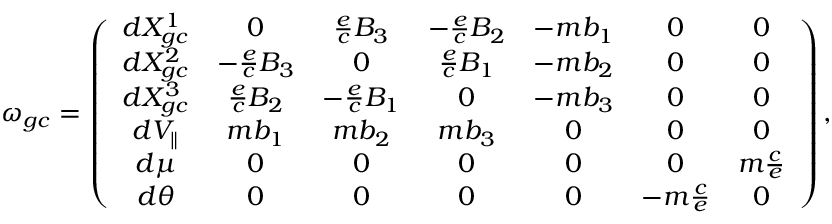<formula> <loc_0><loc_0><loc_500><loc_500>\omega _ { g c } = \left ( \begin{array} { c c c c c c c } { d X _ { g c } ^ { 1 } } & { 0 } & { \frac { e } { c } B _ { 3 } } & { - \frac { e } { c } B _ { 2 } } & { - m b _ { 1 } } & { 0 } & { 0 } \\ { d X _ { g c } ^ { 2 } } & { - \frac { e } { c } B _ { 3 } } & { 0 } & { \frac { e } { c } B _ { 1 } } & { - m b _ { 2 } } & { 0 } & { 0 } \\ { d X _ { g c } ^ { 3 } } & { \frac { e } { c } B _ { 2 } } & { - \frac { e } { c } B _ { 1 } } & { 0 } & { - m b _ { 3 } } & { 0 } & { 0 } \\ { d V _ { \| } } & { m b _ { 1 } } & { m b _ { 2 } } & { m b _ { 3 } } & { 0 } & { 0 } & { 0 } \\ { d \mu } & { 0 } & { 0 } & { 0 } & { 0 } & { 0 } & { m \frac { c } { e } } \\ { d \theta } & { 0 } & { 0 } & { 0 } & { 0 } & { - m \frac { c } { e } } & { 0 } \end{array} \right ) ,</formula> 